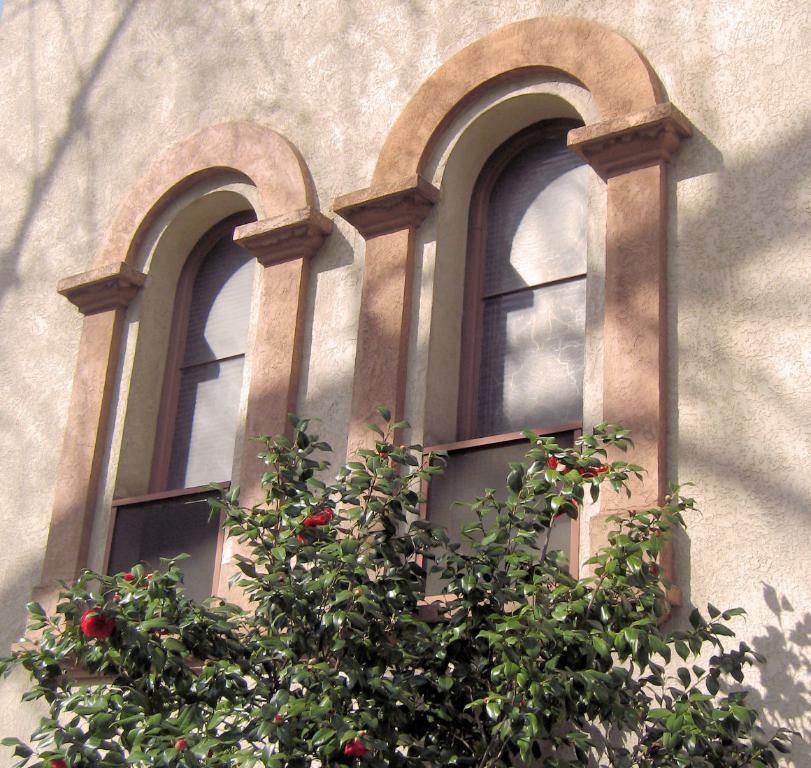How would you summarize this image in a sentence or two? In this image we can see a wall and windows of a building. We can also see a plant with flowers. 